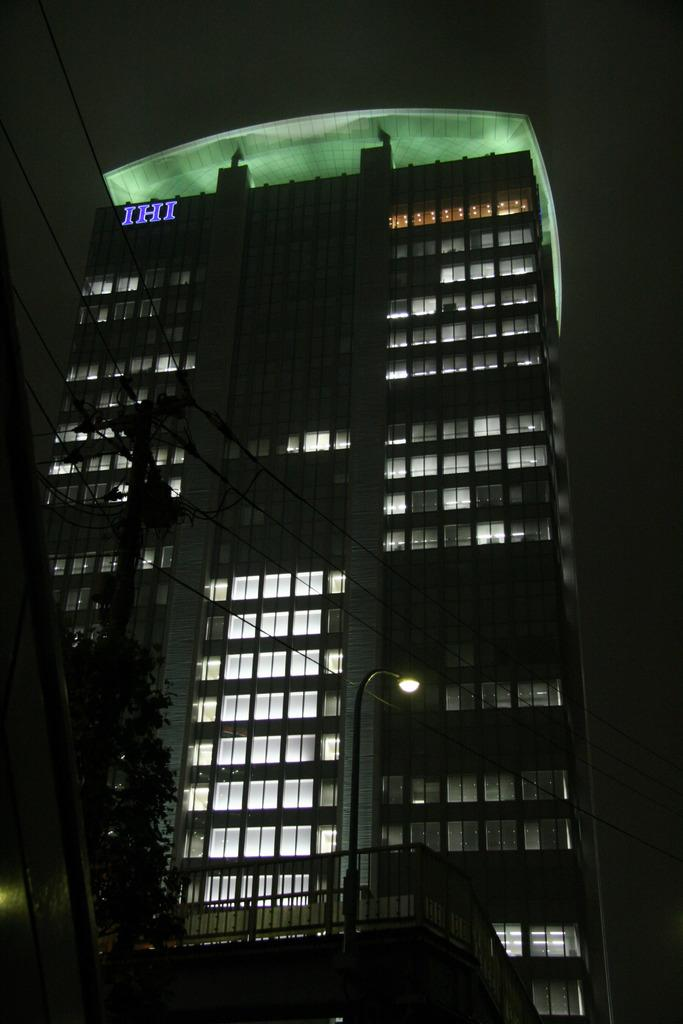What is the main subject of the image? The main subject of the image is a building. Can you describe the background of the image? The background of the image is dark. What type of harmony is being played in the background of the image? There is no music or harmony present in the image; it only features a building and a dark background. 